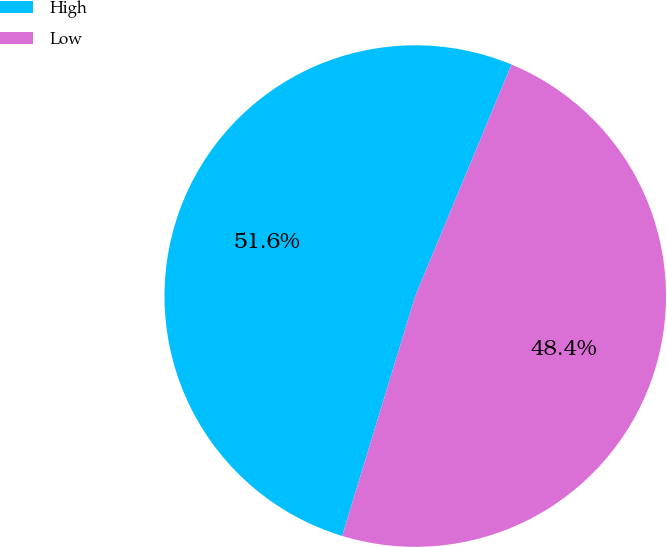Convert chart to OTSL. <chart><loc_0><loc_0><loc_500><loc_500><pie_chart><fcel>High<fcel>Low<nl><fcel>51.56%<fcel>48.44%<nl></chart> 